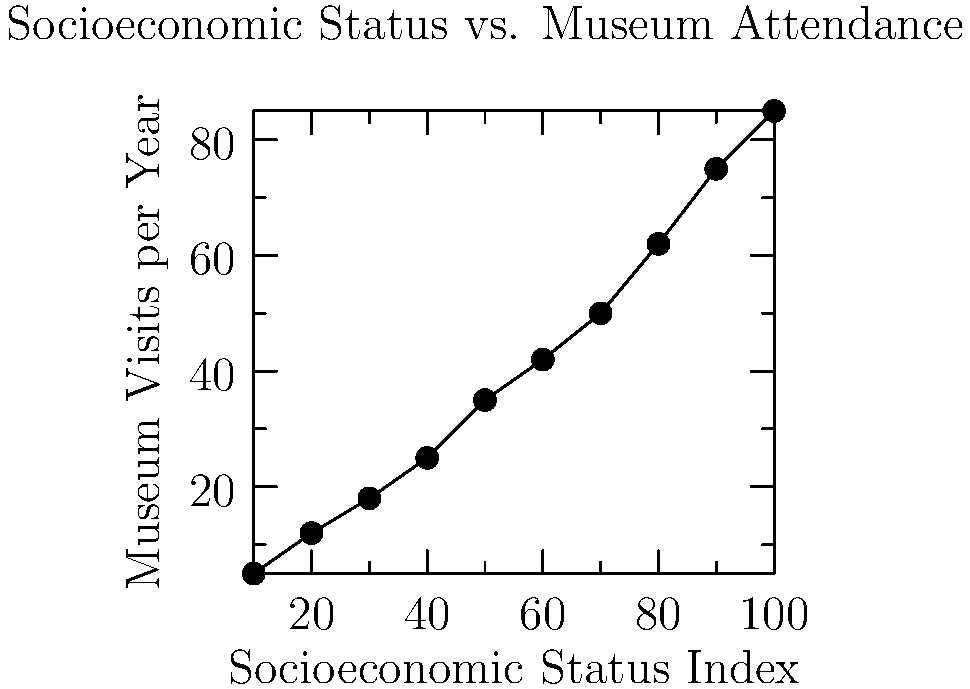Based on the scatter plot showing the relationship between socioeconomic status and annual museum visits, what type of correlation is observed, and how might this information inform strategies for increasing museum attendance among underrepresented communities? To analyze the correlation and its implications, let's follow these steps:

1. Observe the overall trend:
   The data points show an upward trend from left to right.

2. Identify the correlation type:
   As socioeconomic status increases, the number of museum visits also increases. This indicates a positive correlation.

3. Assess the strength of the correlation:
   The points form a relatively tight pattern along the trend line, suggesting a strong positive correlation.

4. Calculate the correlation coefficient:
   While we can't calculate the exact coefficient without the raw data, visually, it appears to be close to 1, indicating a strong positive correlation.

5. Interpret the relationship:
   Higher socioeconomic status is associated with more frequent museum visits.

6. Consider implications for underrepresented communities:
   - These communities often have lower socioeconomic status, which may contribute to lower museum attendance.
   - Barriers may include costs associated with visits, lack of transportation, or feeling unwelcome in museum spaces.

7. Develop strategies to increase attendance:
   - Implement free or reduced admission programs for low-income visitors.
   - Organize transportation services from underrepresented neighborhoods.
   - Create outreach programs that bring museum experiences to communities.
   - Develop exhibits and programs that reflect the cultures and interests of underrepresented groups.
   - Provide multilingual resources and diverse staff representation.

8. Consider the limitations of the data:
   - Correlation does not imply causation; other factors may influence museum attendance.
   - The sample may not fully represent all communities or socioeconomic levels.

By understanding this correlation, social workers can advocate for targeted interventions that address the specific barriers faced by underrepresented communities in accessing museum programs.
Answer: Strong positive correlation; implement targeted programs addressing economic barriers and cultural relevance. 